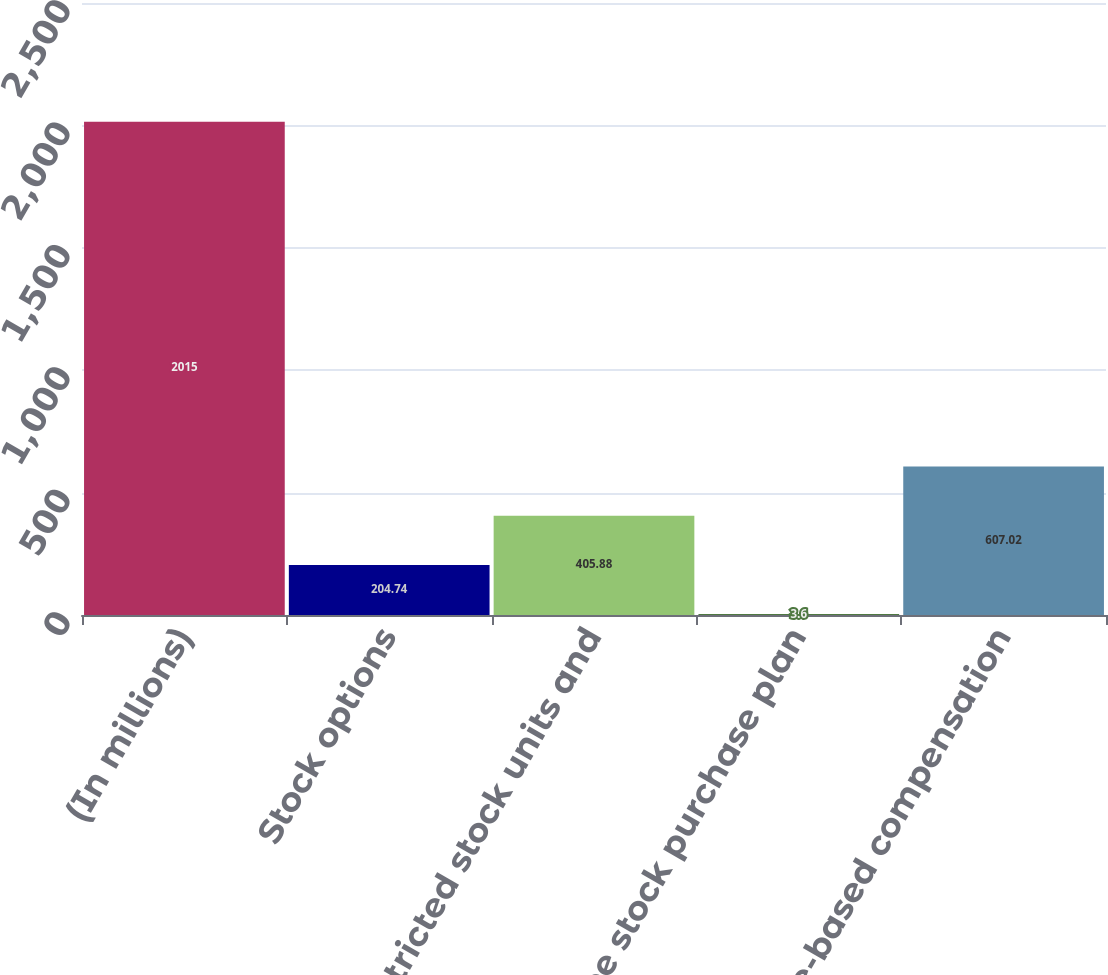Convert chart. <chart><loc_0><loc_0><loc_500><loc_500><bar_chart><fcel>(In millions)<fcel>Stock options<fcel>Restricted stock units and<fcel>Employee stock purchase plan<fcel>Total share-based compensation<nl><fcel>2015<fcel>204.74<fcel>405.88<fcel>3.6<fcel>607.02<nl></chart> 